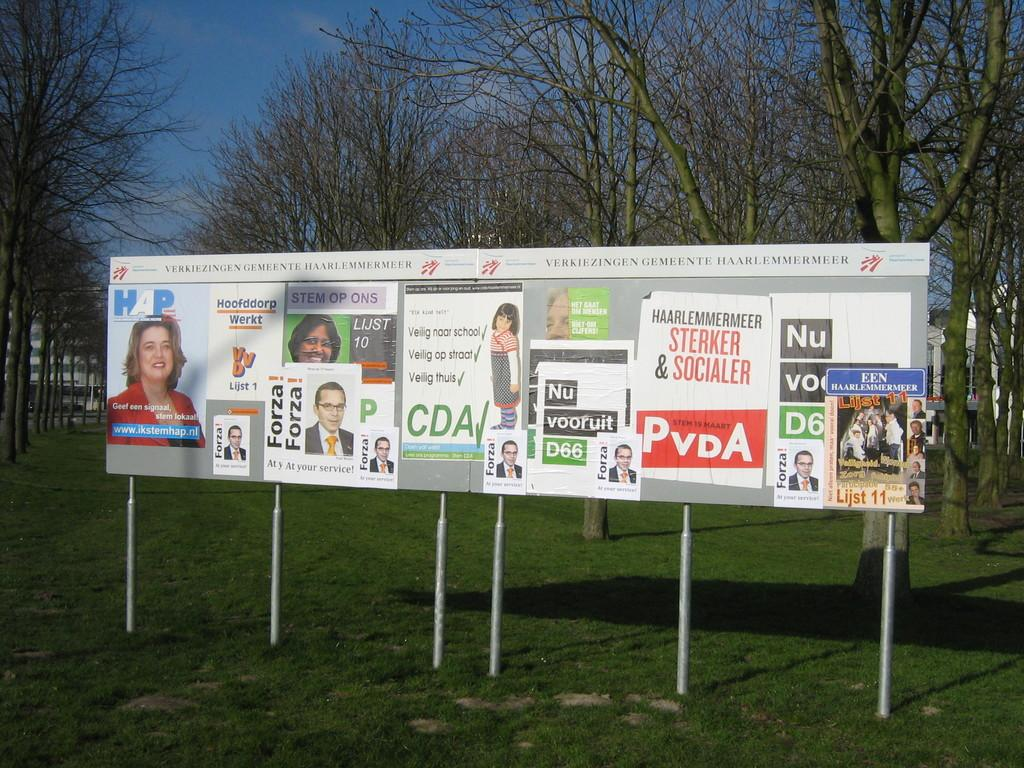Provide a one-sentence caption for the provided image. Political posters for politicians named Forza and Lijst, among others, are pasted to some signboards. 